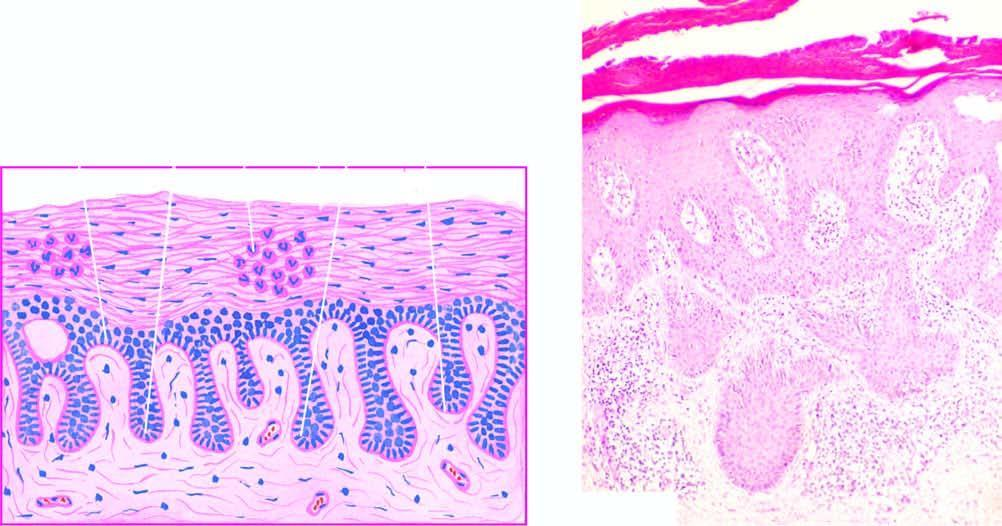what is there of the rete ridges with thickening of their lower portion?
Answer the question using a single word or phrase. Regular elongation 